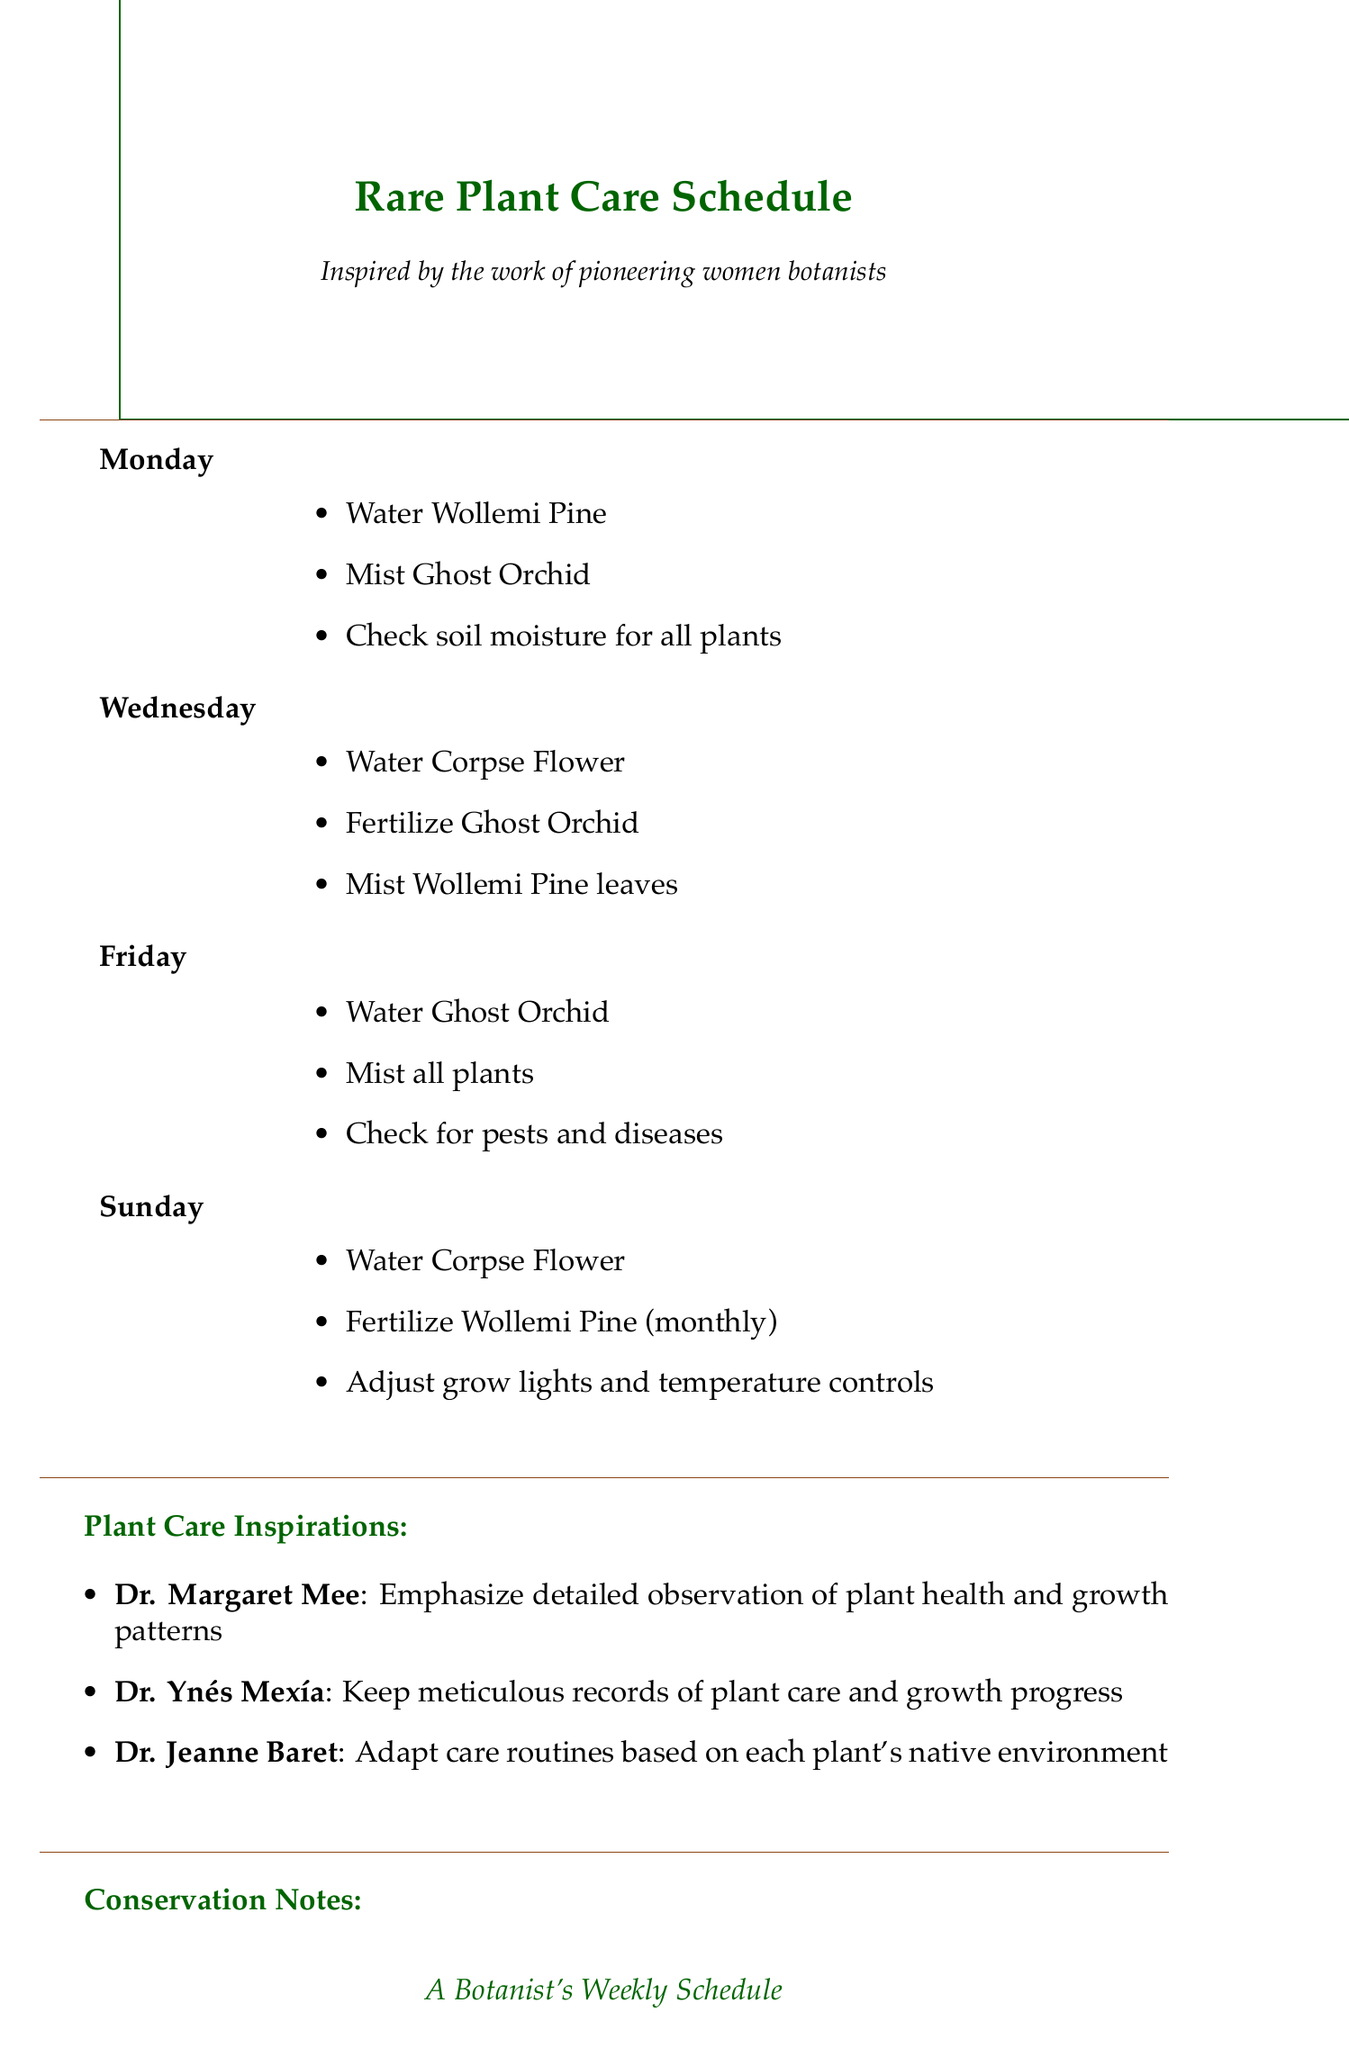What day do you water the Wollemi Pine? The document specifies that the Wollemi Pine is watered on Monday.
Answer: Monday How often is the Ghost Orchid fertilized? The schedule states that the Ghost Orchid is fertilized weekly.
Answer: Weekly What special care is given to the Corpse Flower? The document notes that the Corpse Flower requires maintenance of soil temperature around 80°F (27°C).
Answer: Maintain soil temperature around 80°F (27°C) Who is noted for discovering and illustrating Amazonian plant species? The document mentions Dr. Margaret Mee for her contributions in this area.
Answer: Dr. Margaret Mee What is the frequency of watering for the Corpse Flower during dormancy? According to the document, the frequency is reduced to once a month during dormancy.
Answer: Once a month On which day do you mist the Ghost Orchid? The schedule indicates that the Ghost Orchid is misted on Monday.
Answer: Monday What organization focuses on ex-situ conservation of rare plant species? The document states that Botanic Gardens Conservation International focuses on ex-situ conservation.
Answer: Botanic Gardens Conservation International What historical trend does the document identify during the Victorian Era? The document outlines that the trend was rare plant collection and cultivation in private conservatories.
Answer: Rare plant collection and cultivation in private conservatories How many plant specimens did Dr. Ynés Mexía collect? The document specifies that Dr. Ynés Mexía collected over 150,000 plant specimens.
Answer: Over 150,000 plant specimens 